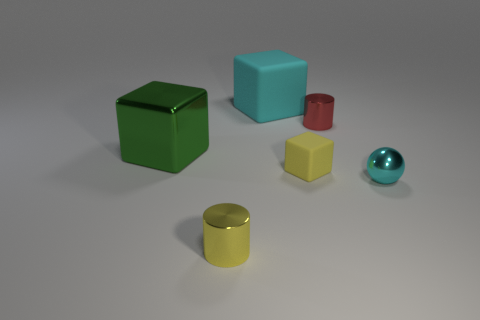Subtract all cyan cylinders. Subtract all purple balls. How many cylinders are left? 2 Add 2 green matte cubes. How many objects exist? 8 Subtract all cylinders. How many objects are left? 4 Subtract all tiny gray rubber things. Subtract all tiny red cylinders. How many objects are left? 5 Add 5 tiny shiny cylinders. How many tiny shiny cylinders are left? 7 Add 5 tiny shiny objects. How many tiny shiny objects exist? 8 Subtract 1 cyan cubes. How many objects are left? 5 